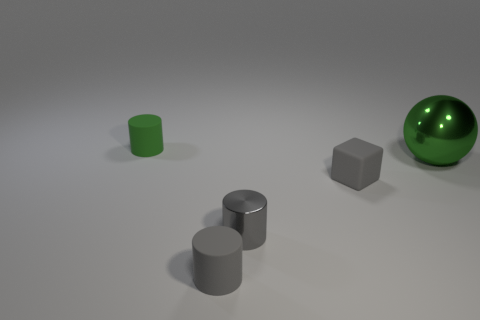What is the color of the tiny metallic object that is the same shape as the green rubber object?
Offer a very short reply. Gray. What number of matte things are behind the gray metal cylinder and in front of the green matte object?
Offer a terse response. 1. Are the tiny green cylinder on the left side of the tiny shiny cylinder and the green ball made of the same material?
Provide a short and direct response. No. The green thing that is in front of the rubber cylinder to the left of the small gray thing in front of the tiny gray metal thing is what shape?
Give a very brief answer. Sphere. Are there an equal number of small matte blocks on the left side of the big metal object and shiny cylinders to the right of the tiny metal thing?
Give a very brief answer. No. There is a metal cylinder that is the same size as the cube; what is its color?
Make the answer very short. Gray. What number of tiny objects are metallic things or gray cylinders?
Make the answer very short. 2. What is the object that is to the right of the small gray metal cylinder and on the left side of the green metallic object made of?
Make the answer very short. Rubber. Is the shape of the metallic object in front of the small matte block the same as the rubber thing behind the large metal ball?
Offer a terse response. Yes. What is the shape of the tiny matte thing that is the same color as the large thing?
Offer a very short reply. Cylinder. 